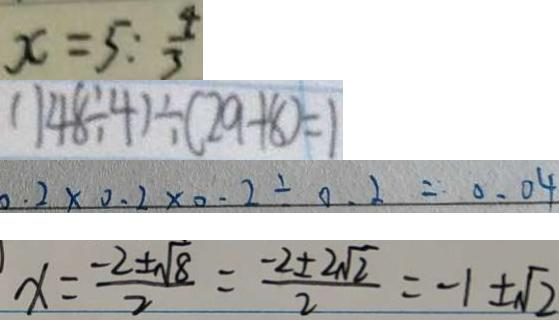<formula> <loc_0><loc_0><loc_500><loc_500>x = 5 : \frac { 4 } { 3 } 
 ( 1 4 8 \div 4 ) \div ( 2 9 + 8 ) = 1 
 0 . 2 \times 0 . 2 \times 0 . 2 \div 0 . 2 = 0 . 0 4 
 x = \frac { - 2 \pm \sqrt { 8 } } { 2 } = \frac { - 2 \pm 2 \sqrt { 2 } } { 2 } = - 1 \pm \sqrt { 2 }</formula> 